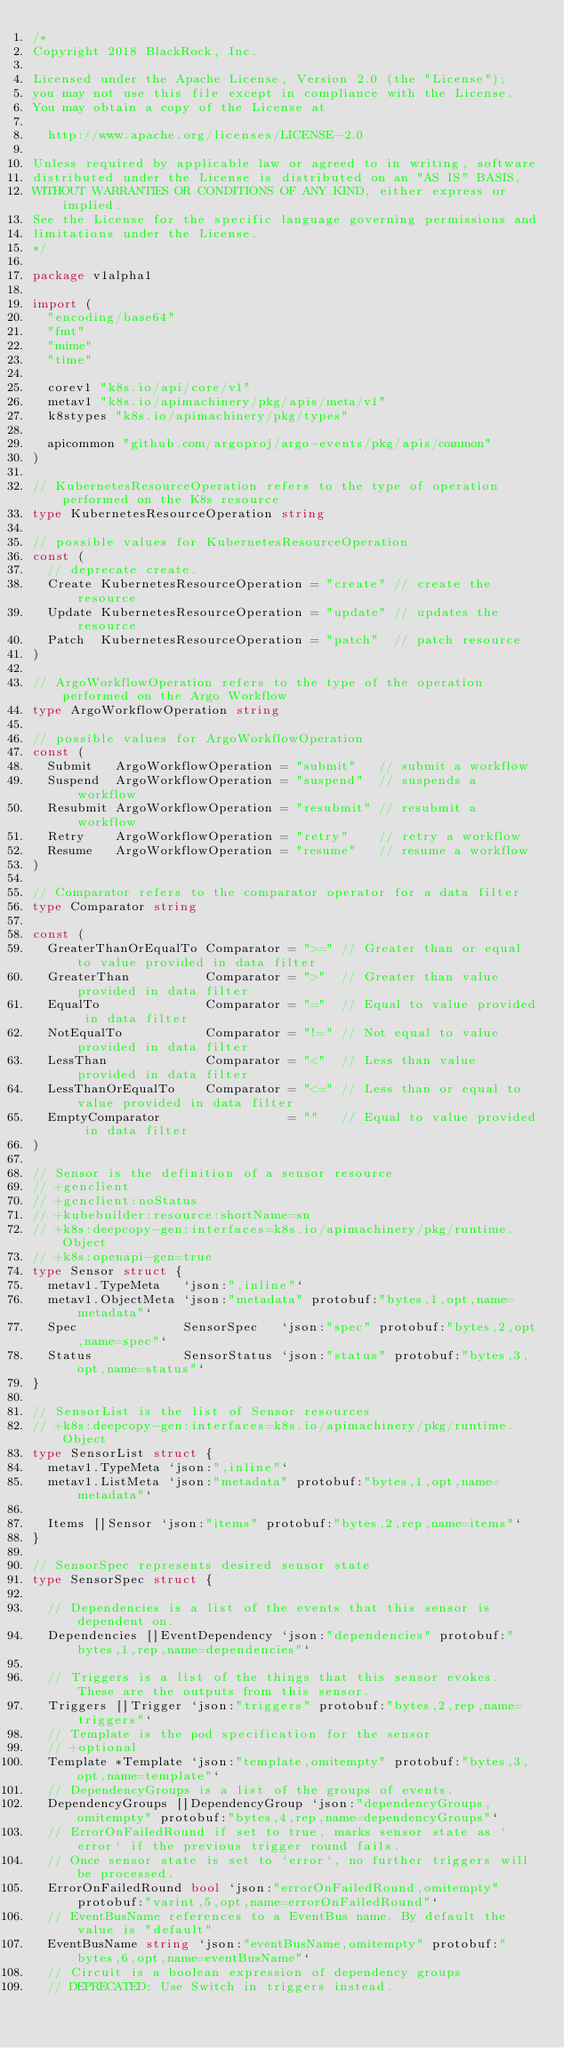Convert code to text. <code><loc_0><loc_0><loc_500><loc_500><_Go_>/*
Copyright 2018 BlackRock, Inc.

Licensed under the Apache License, Version 2.0 (the "License");
you may not use this file except in compliance with the License.
You may obtain a copy of the License at

	http://www.apache.org/licenses/LICENSE-2.0

Unless required by applicable law or agreed to in writing, software
distributed under the License is distributed on an "AS IS" BASIS,
WITHOUT WARRANTIES OR CONDITIONS OF ANY KIND, either express or implied.
See the License for the specific language governing permissions and
limitations under the License.
*/

package v1alpha1

import (
	"encoding/base64"
	"fmt"
	"mime"
	"time"

	corev1 "k8s.io/api/core/v1"
	metav1 "k8s.io/apimachinery/pkg/apis/meta/v1"
	k8stypes "k8s.io/apimachinery/pkg/types"

	apicommon "github.com/argoproj/argo-events/pkg/apis/common"
)

// KubernetesResourceOperation refers to the type of operation performed on the K8s resource
type KubernetesResourceOperation string

// possible values for KubernetesResourceOperation
const (
	// deprecate create.
	Create KubernetesResourceOperation = "create" // create the resource
	Update KubernetesResourceOperation = "update" // updates the resource
	Patch  KubernetesResourceOperation = "patch"  // patch resource
)

// ArgoWorkflowOperation refers to the type of the operation performed on the Argo Workflow
type ArgoWorkflowOperation string

// possible values for ArgoWorkflowOperation
const (
	Submit   ArgoWorkflowOperation = "submit"   // submit a workflow
	Suspend  ArgoWorkflowOperation = "suspend"  // suspends a workflow
	Resubmit ArgoWorkflowOperation = "resubmit" // resubmit a workflow
	Retry    ArgoWorkflowOperation = "retry"    // retry a workflow
	Resume   ArgoWorkflowOperation = "resume"   // resume a workflow
)

// Comparator refers to the comparator operator for a data filter
type Comparator string

const (
	GreaterThanOrEqualTo Comparator = ">=" // Greater than or equal to value provided in data filter
	GreaterThan          Comparator = ">"  // Greater than value provided in data filter
	EqualTo              Comparator = "="  // Equal to value provided in data filter
	NotEqualTo           Comparator = "!=" // Not equal to value provided in data filter
	LessThan             Comparator = "<"  // Less than value provided in data filter
	LessThanOrEqualTo    Comparator = "<=" // Less than or equal to value provided in data filter
	EmptyComparator                 = ""   // Equal to value provided in data filter
)

// Sensor is the definition of a sensor resource
// +genclient
// +genclient:noStatus
// +kubebuilder:resource:shortName=sn
// +k8s:deepcopy-gen:interfaces=k8s.io/apimachinery/pkg/runtime.Object
// +k8s:openapi-gen=true
type Sensor struct {
	metav1.TypeMeta   `json:",inline"`
	metav1.ObjectMeta `json:"metadata" protobuf:"bytes,1,opt,name=metadata"`
	Spec              SensorSpec   `json:"spec" protobuf:"bytes,2,opt,name=spec"`
	Status            SensorStatus `json:"status" protobuf:"bytes,3,opt,name=status"`
}

// SensorList is the list of Sensor resources
// +k8s:deepcopy-gen:interfaces=k8s.io/apimachinery/pkg/runtime.Object
type SensorList struct {
	metav1.TypeMeta `json:",inline"`
	metav1.ListMeta `json:"metadata" protobuf:"bytes,1,opt,name=metadata"`

	Items []Sensor `json:"items" protobuf:"bytes,2,rep,name=items"`
}

// SensorSpec represents desired sensor state
type SensorSpec struct {

	// Dependencies is a list of the events that this sensor is dependent on.
	Dependencies []EventDependency `json:"dependencies" protobuf:"bytes,1,rep,name=dependencies"`

	// Triggers is a list of the things that this sensor evokes. These are the outputs from this sensor.
	Triggers []Trigger `json:"triggers" protobuf:"bytes,2,rep,name=triggers"`
	// Template is the pod specification for the sensor
	// +optional
	Template *Template `json:"template,omitempty" protobuf:"bytes,3,opt,name=template"`
	// DependencyGroups is a list of the groups of events.
	DependencyGroups []DependencyGroup `json:"dependencyGroups,omitempty" protobuf:"bytes,4,rep,name=dependencyGroups"`
	// ErrorOnFailedRound if set to true, marks sensor state as `error` if the previous trigger round fails.
	// Once sensor state is set to `error`, no further triggers will be processed.
	ErrorOnFailedRound bool `json:"errorOnFailedRound,omitempty" protobuf:"varint,5,opt,name=errorOnFailedRound"`
	// EventBusName references to a EventBus name. By default the value is "default"
	EventBusName string `json:"eventBusName,omitempty" protobuf:"bytes,6,opt,name=eventBusName"`
	// Circuit is a boolean expression of dependency groups
	// DEPRECATED: Use Switch in triggers instead.</code> 